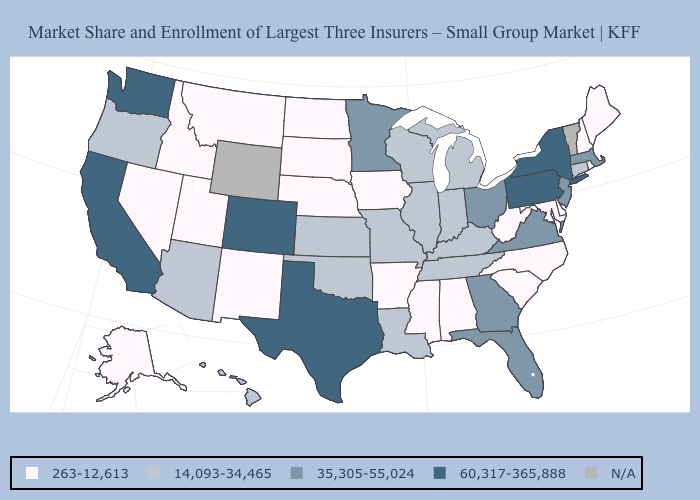What is the lowest value in the Northeast?
Short answer required. 263-12,613. Name the states that have a value in the range N/A?
Keep it brief. Vermont, Wyoming. What is the value of Mississippi?
Quick response, please. 263-12,613. Among the states that border New Jersey , does Delaware have the lowest value?
Short answer required. Yes. Which states hav the highest value in the MidWest?
Short answer required. Minnesota, Ohio. Among the states that border Minnesota , which have the highest value?
Write a very short answer. Wisconsin. Name the states that have a value in the range 60,317-365,888?
Be succinct. California, Colorado, New York, Pennsylvania, Texas, Washington. Among the states that border Rhode Island , which have the lowest value?
Answer briefly. Connecticut. Which states have the highest value in the USA?
Keep it brief. California, Colorado, New York, Pennsylvania, Texas, Washington. Is the legend a continuous bar?
Be succinct. No. What is the value of New York?
Quick response, please. 60,317-365,888. Among the states that border Kentucky , does Missouri have the highest value?
Concise answer only. No. Does the map have missing data?
Short answer required. Yes. 